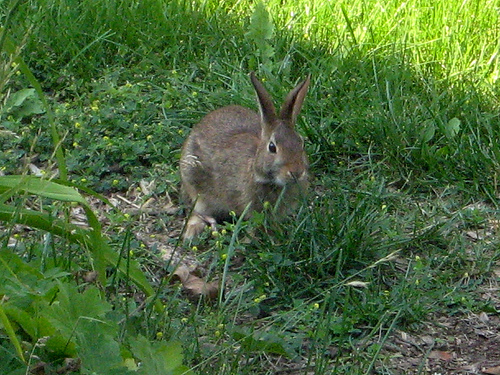<image>
Is there a rabbit behind the grass? Yes. From this viewpoint, the rabbit is positioned behind the grass, with the grass partially or fully occluding the rabbit. 